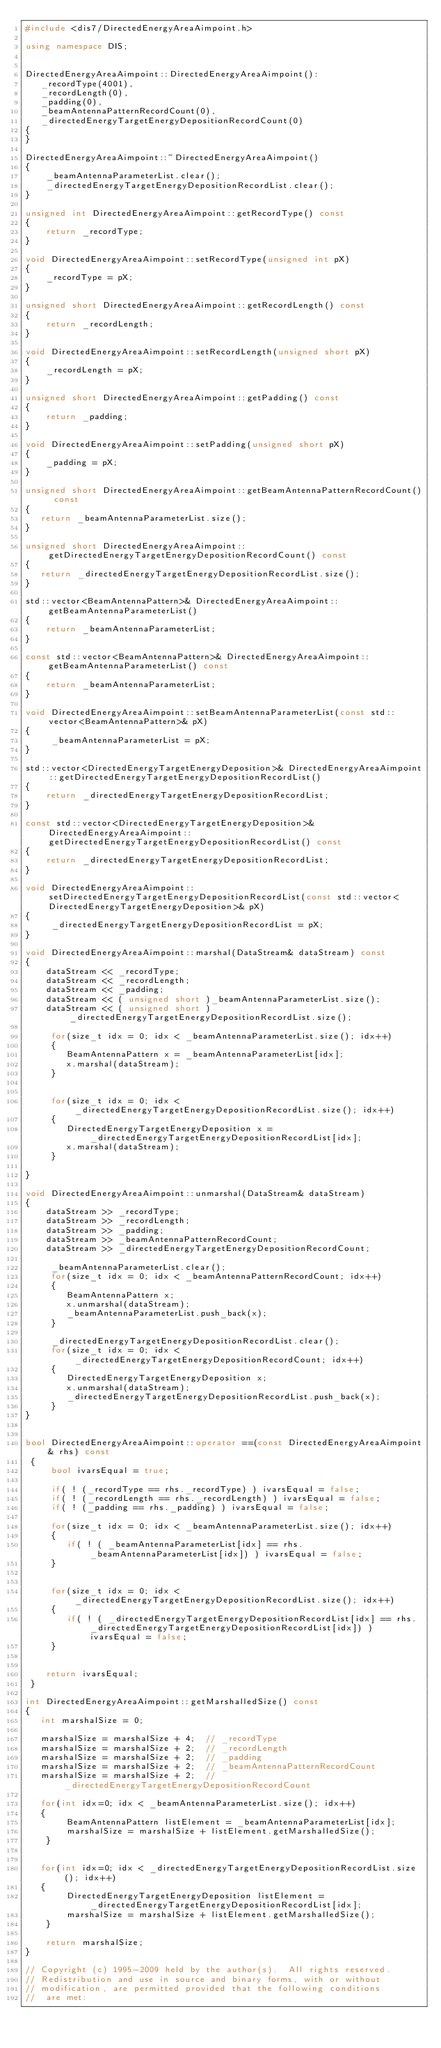<code> <loc_0><loc_0><loc_500><loc_500><_C++_>#include <dis7/DirectedEnergyAreaAimpoint.h>

using namespace DIS;


DirectedEnergyAreaAimpoint::DirectedEnergyAreaAimpoint():
   _recordType(4001), 
   _recordLength(0), 
   _padding(0), 
   _beamAntennaPatternRecordCount(0), 
   _directedEnergyTargetEnergyDepositionRecordCount(0)
{
}

DirectedEnergyAreaAimpoint::~DirectedEnergyAreaAimpoint()
{
    _beamAntennaParameterList.clear();
    _directedEnergyTargetEnergyDepositionRecordList.clear();
}

unsigned int DirectedEnergyAreaAimpoint::getRecordType() const
{
    return _recordType;
}

void DirectedEnergyAreaAimpoint::setRecordType(unsigned int pX)
{
    _recordType = pX;
}

unsigned short DirectedEnergyAreaAimpoint::getRecordLength() const
{
    return _recordLength;
}

void DirectedEnergyAreaAimpoint::setRecordLength(unsigned short pX)
{
    _recordLength = pX;
}

unsigned short DirectedEnergyAreaAimpoint::getPadding() const
{
    return _padding;
}

void DirectedEnergyAreaAimpoint::setPadding(unsigned short pX)
{
    _padding = pX;
}

unsigned short DirectedEnergyAreaAimpoint::getBeamAntennaPatternRecordCount() const
{
   return _beamAntennaParameterList.size();
}

unsigned short DirectedEnergyAreaAimpoint::getDirectedEnergyTargetEnergyDepositionRecordCount() const
{
   return _directedEnergyTargetEnergyDepositionRecordList.size();
}

std::vector<BeamAntennaPattern>& DirectedEnergyAreaAimpoint::getBeamAntennaParameterList() 
{
    return _beamAntennaParameterList;
}

const std::vector<BeamAntennaPattern>& DirectedEnergyAreaAimpoint::getBeamAntennaParameterList() const
{
    return _beamAntennaParameterList;
}

void DirectedEnergyAreaAimpoint::setBeamAntennaParameterList(const std::vector<BeamAntennaPattern>& pX)
{
     _beamAntennaParameterList = pX;
}

std::vector<DirectedEnergyTargetEnergyDeposition>& DirectedEnergyAreaAimpoint::getDirectedEnergyTargetEnergyDepositionRecordList() 
{
    return _directedEnergyTargetEnergyDepositionRecordList;
}

const std::vector<DirectedEnergyTargetEnergyDeposition>& DirectedEnergyAreaAimpoint::getDirectedEnergyTargetEnergyDepositionRecordList() const
{
    return _directedEnergyTargetEnergyDepositionRecordList;
}

void DirectedEnergyAreaAimpoint::setDirectedEnergyTargetEnergyDepositionRecordList(const std::vector<DirectedEnergyTargetEnergyDeposition>& pX)
{
     _directedEnergyTargetEnergyDepositionRecordList = pX;
}

void DirectedEnergyAreaAimpoint::marshal(DataStream& dataStream) const
{
    dataStream << _recordType;
    dataStream << _recordLength;
    dataStream << _padding;
    dataStream << ( unsigned short )_beamAntennaParameterList.size();
    dataStream << ( unsigned short )_directedEnergyTargetEnergyDepositionRecordList.size();

     for(size_t idx = 0; idx < _beamAntennaParameterList.size(); idx++)
     {
        BeamAntennaPattern x = _beamAntennaParameterList[idx];
        x.marshal(dataStream);
     }


     for(size_t idx = 0; idx < _directedEnergyTargetEnergyDepositionRecordList.size(); idx++)
     {
        DirectedEnergyTargetEnergyDeposition x = _directedEnergyTargetEnergyDepositionRecordList[idx];
        x.marshal(dataStream);
     }

}

void DirectedEnergyAreaAimpoint::unmarshal(DataStream& dataStream)
{
    dataStream >> _recordType;
    dataStream >> _recordLength;
    dataStream >> _padding;
    dataStream >> _beamAntennaPatternRecordCount;
    dataStream >> _directedEnergyTargetEnergyDepositionRecordCount;

     _beamAntennaParameterList.clear();
     for(size_t idx = 0; idx < _beamAntennaPatternRecordCount; idx++)
     {
        BeamAntennaPattern x;
        x.unmarshal(dataStream);
        _beamAntennaParameterList.push_back(x);
     }

     _directedEnergyTargetEnergyDepositionRecordList.clear();
     for(size_t idx = 0; idx < _directedEnergyTargetEnergyDepositionRecordCount; idx++)
     {
        DirectedEnergyTargetEnergyDeposition x;
        x.unmarshal(dataStream);
        _directedEnergyTargetEnergyDepositionRecordList.push_back(x);
     }
}


bool DirectedEnergyAreaAimpoint::operator ==(const DirectedEnergyAreaAimpoint& rhs) const
 {
     bool ivarsEqual = true;

     if( ! (_recordType == rhs._recordType) ) ivarsEqual = false;
     if( ! (_recordLength == rhs._recordLength) ) ivarsEqual = false;
     if( ! (_padding == rhs._padding) ) ivarsEqual = false;

     for(size_t idx = 0; idx < _beamAntennaParameterList.size(); idx++)
     {
        if( ! ( _beamAntennaParameterList[idx] == rhs._beamAntennaParameterList[idx]) ) ivarsEqual = false;
     }


     for(size_t idx = 0; idx < _directedEnergyTargetEnergyDepositionRecordList.size(); idx++)
     {
        if( ! ( _directedEnergyTargetEnergyDepositionRecordList[idx] == rhs._directedEnergyTargetEnergyDepositionRecordList[idx]) ) ivarsEqual = false;
     }


    return ivarsEqual;
 }

int DirectedEnergyAreaAimpoint::getMarshalledSize() const
{
   int marshalSize = 0;

   marshalSize = marshalSize + 4;  // _recordType
   marshalSize = marshalSize + 2;  // _recordLength
   marshalSize = marshalSize + 2;  // _padding
   marshalSize = marshalSize + 2;  // _beamAntennaPatternRecordCount
   marshalSize = marshalSize + 2;  // _directedEnergyTargetEnergyDepositionRecordCount

   for(int idx=0; idx < _beamAntennaParameterList.size(); idx++)
   {
        BeamAntennaPattern listElement = _beamAntennaParameterList[idx];
        marshalSize = marshalSize + listElement.getMarshalledSize();
    }


   for(int idx=0; idx < _directedEnergyTargetEnergyDepositionRecordList.size(); idx++)
   {
        DirectedEnergyTargetEnergyDeposition listElement = _directedEnergyTargetEnergyDepositionRecordList[idx];
        marshalSize = marshalSize + listElement.getMarshalledSize();
    }

    return marshalSize;
}

// Copyright (c) 1995-2009 held by the author(s).  All rights reserved.
// Redistribution and use in source and binary forms, with or without
// modification, are permitted provided that the following conditions
//  are met:</code> 